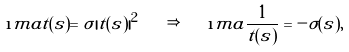<formula> <loc_0><loc_0><loc_500><loc_500>\i m a t ( s ) = \sigma | t ( s ) | ^ { 2 } \quad \Rightarrow \quad \i m a \frac { 1 } { t ( s ) } = - \sigma ( s ) ,</formula> 